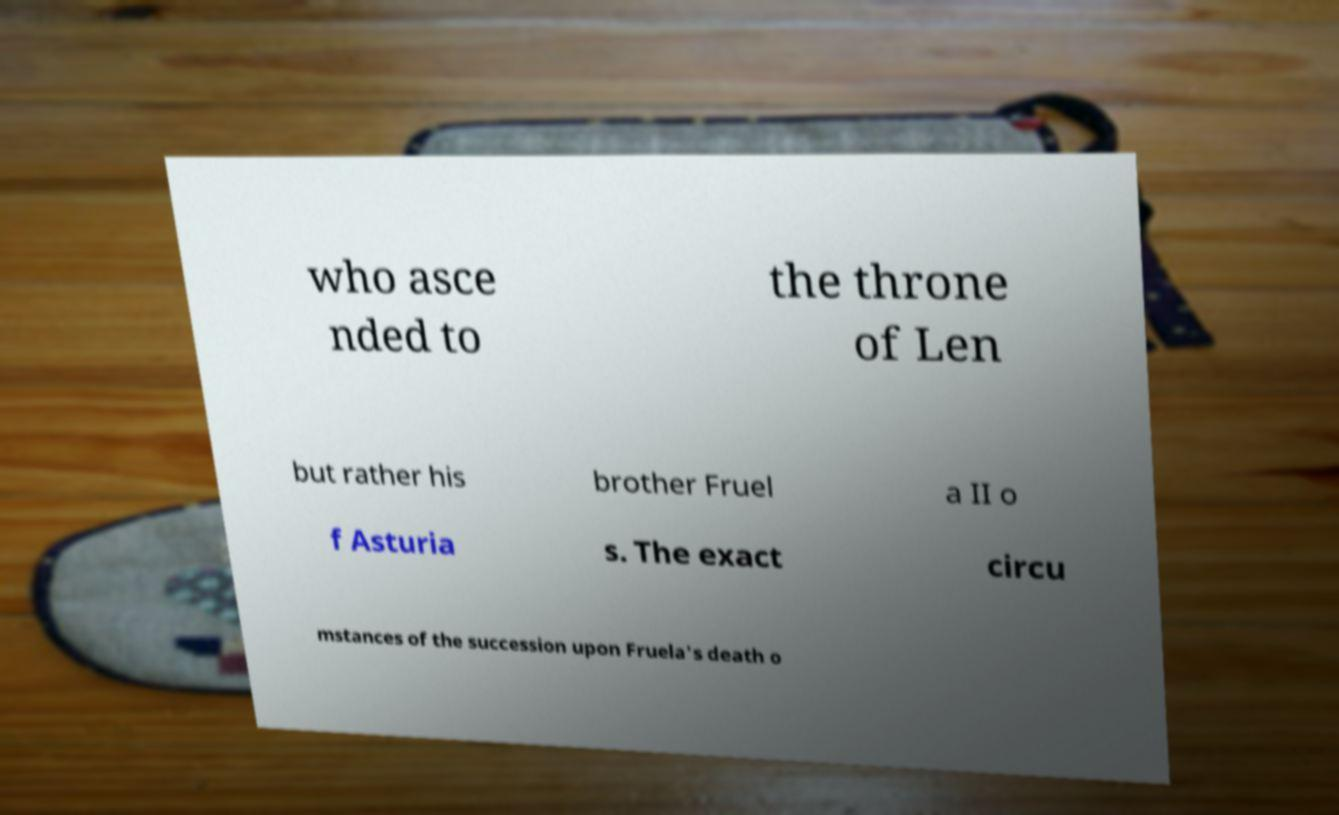Could you assist in decoding the text presented in this image and type it out clearly? who asce nded to the throne of Len but rather his brother Fruel a II o f Asturia s. The exact circu mstances of the succession upon Fruela's death o 